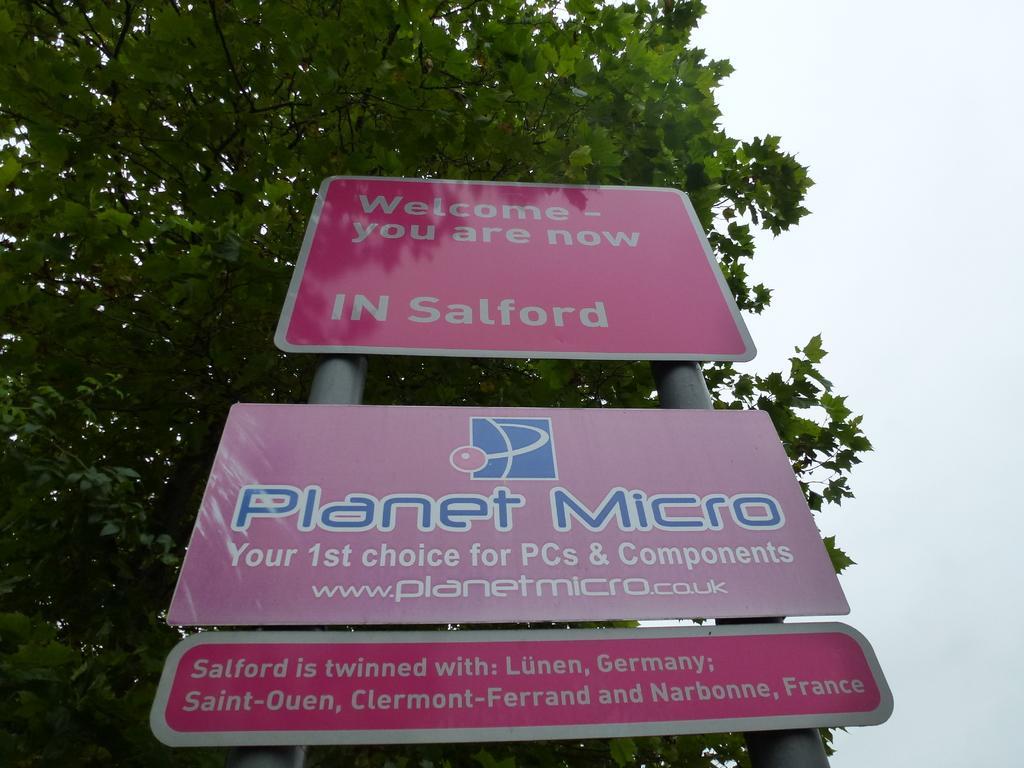Can you describe this image briefly? In this image we can see the boards and poles. In the background, we can see a tree and the sky. 